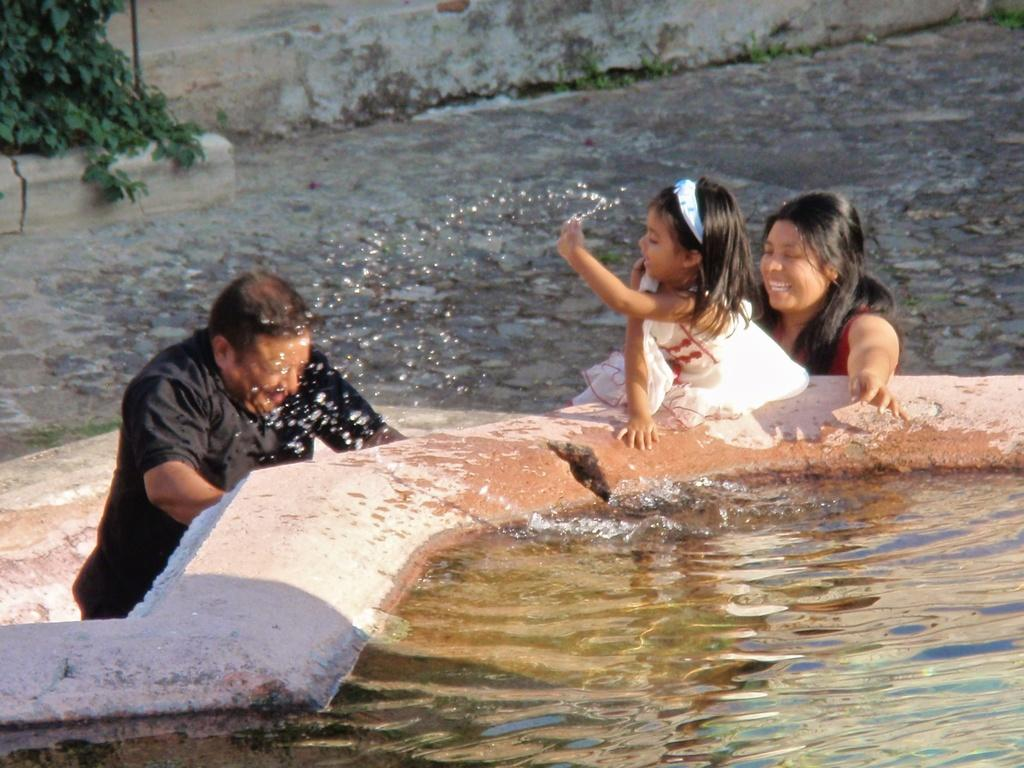How many people are in the image? There are people in the image, but the exact number is not specified. What are the people doing in the image? The people are on the ground and playing with water. What is the condition of the ground around the people? There is water around the people. What can be seen in the top left corner of the image? There are plants in the top left corner of the image. What government policy is being discussed by the people in the image? There is no indication in the image that the people are discussing any government policies. 